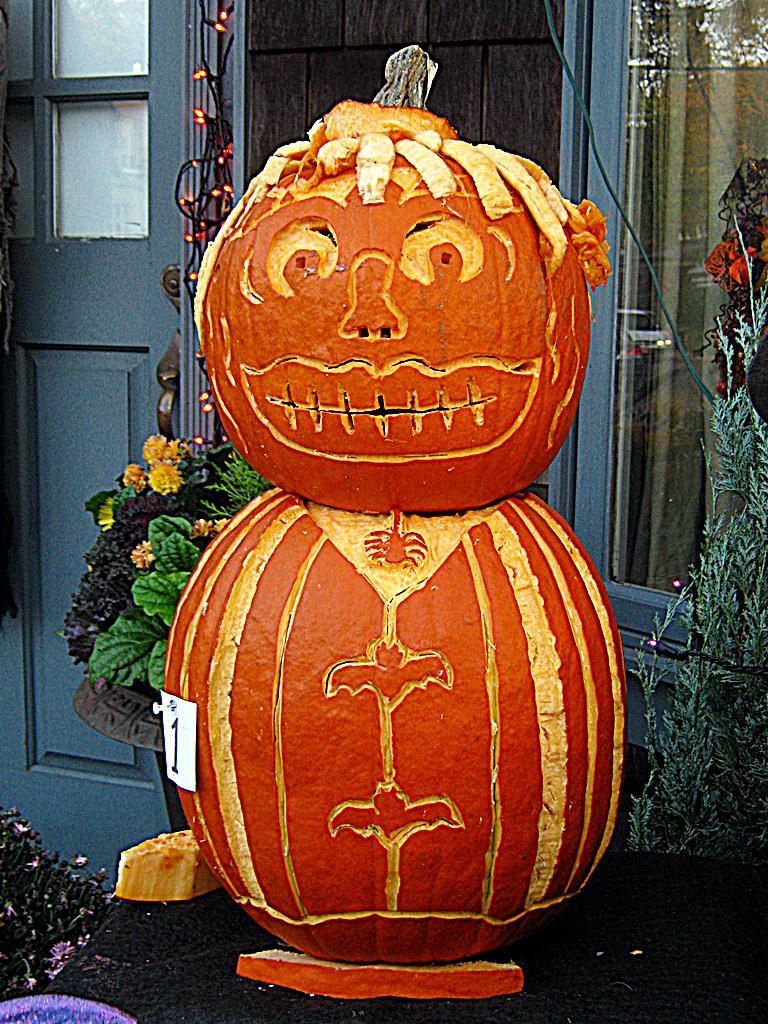What is the color of the decorative object on the ground in the image? The decorative object on the ground is orange in color. What type of architectural feature is present in the image? There is a glass door in the image. What can be seen under the decorative object? The ground is visible in the image. What type of vegetation is present in the image? There are plants in the image. Where is the object located in the bottom left side of the picture? There is an object in the bottom left side of the picture. What type of reward is being given to the plants in the image? There is no reward being given to the plants in the image; they are simply present in the scene. 